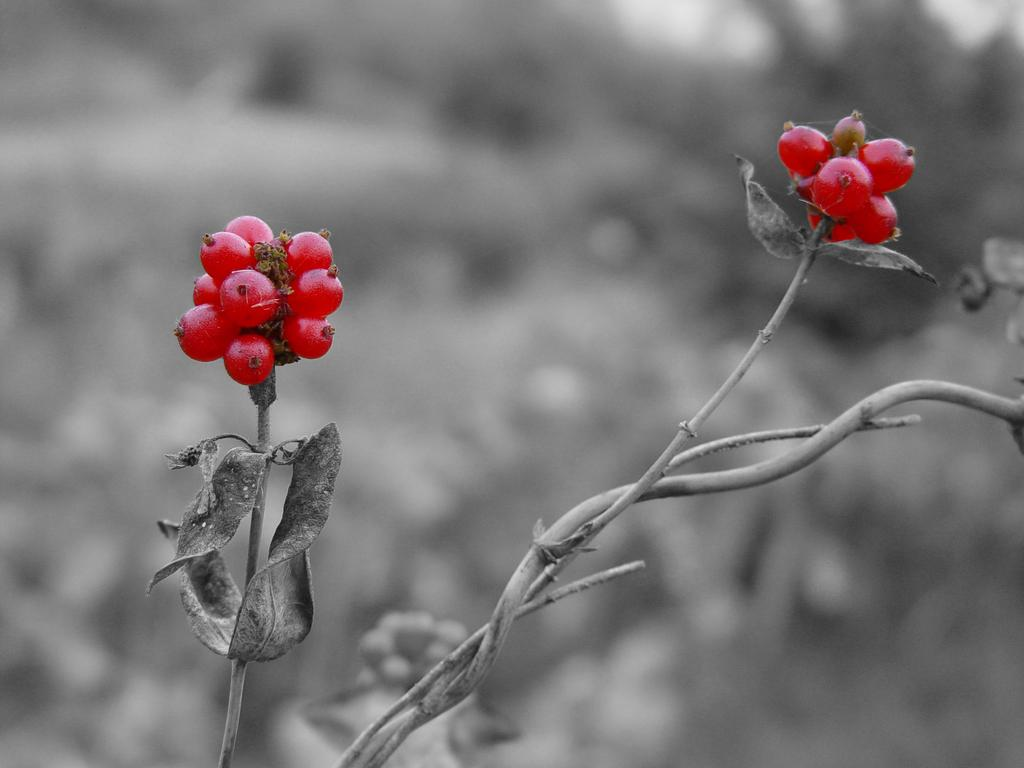What type of plant is visible in the image? There is a plant with berries in the image. Can you describe the background of the image? The background of the image is blurred. How many fingers can be seen holding the plant in the image? There are no fingers or hands visible in the image; it only shows a plant with berries and a blurred background. 